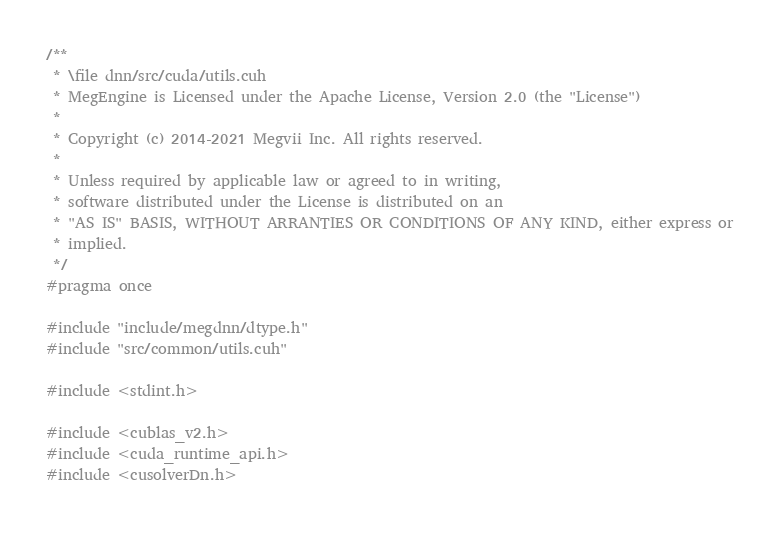<code> <loc_0><loc_0><loc_500><loc_500><_Cuda_>/**
 * \file dnn/src/cuda/utils.cuh
 * MegEngine is Licensed under the Apache License, Version 2.0 (the "License")
 *
 * Copyright (c) 2014-2021 Megvii Inc. All rights reserved.
 *
 * Unless required by applicable law or agreed to in writing,
 * software distributed under the License is distributed on an
 * "AS IS" BASIS, WITHOUT ARRANTIES OR CONDITIONS OF ANY KIND, either express or
 * implied.
 */
#pragma once

#include "include/megdnn/dtype.h"
#include "src/common/utils.cuh"

#include <stdint.h>

#include <cublas_v2.h>
#include <cuda_runtime_api.h>
#include <cusolverDn.h></code> 